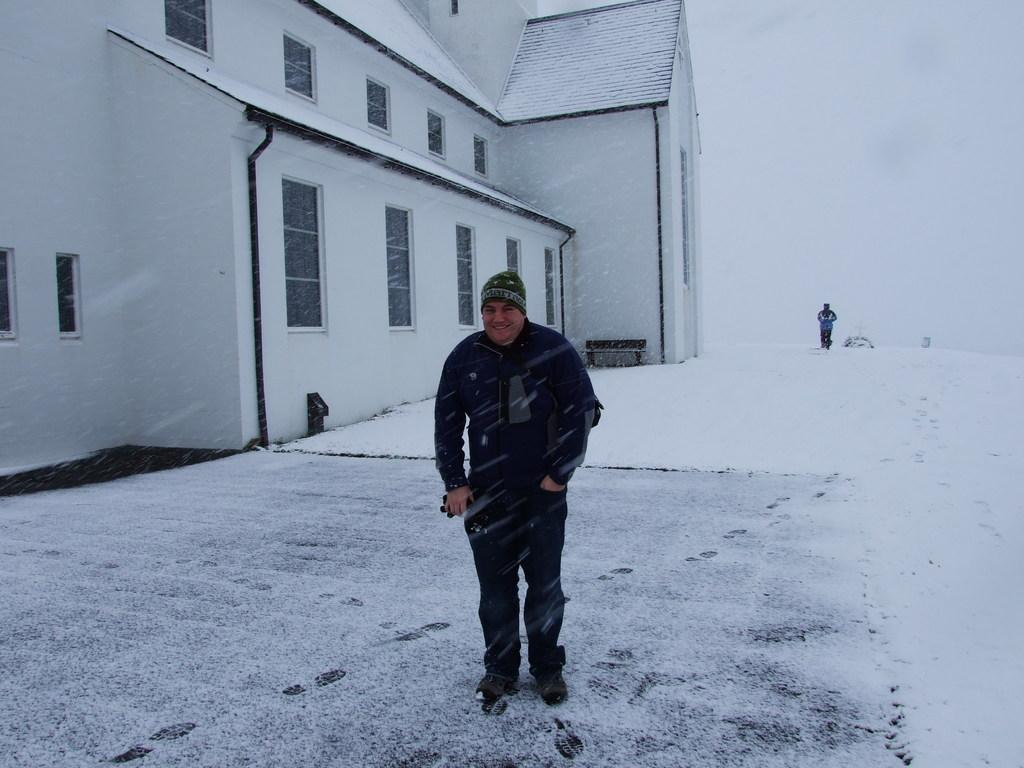How many people are present in the image? There are two people in the image. What is located on the left side of the image? There is a building with windows on the left side of the image. What is the weather like in the image? There is snow visible in the background of the image, indicating a cold or wintry weather. What type of seating is present in the image? There is a bench in the image. What type of frogs can be seen jumping on the bench in the image? There are no frogs present in the image, and therefore no such activity can be observed. What is the purpose of the cake in the image? There is no cake present in the image, so it cannot be used for any purpose. 